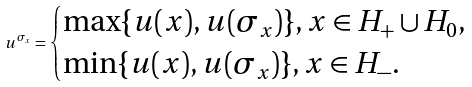Convert formula to latex. <formula><loc_0><loc_0><loc_500><loc_500>u ^ { \sigma _ { x } } = \begin{cases} \max \{ u ( x ) , u ( \sigma _ { x } ) \} , x \in H _ { + } \cup H _ { 0 } , \\ \min \{ u ( x ) , u ( \sigma _ { x } ) \} , x \in H _ { - } . \end{cases}</formula> 